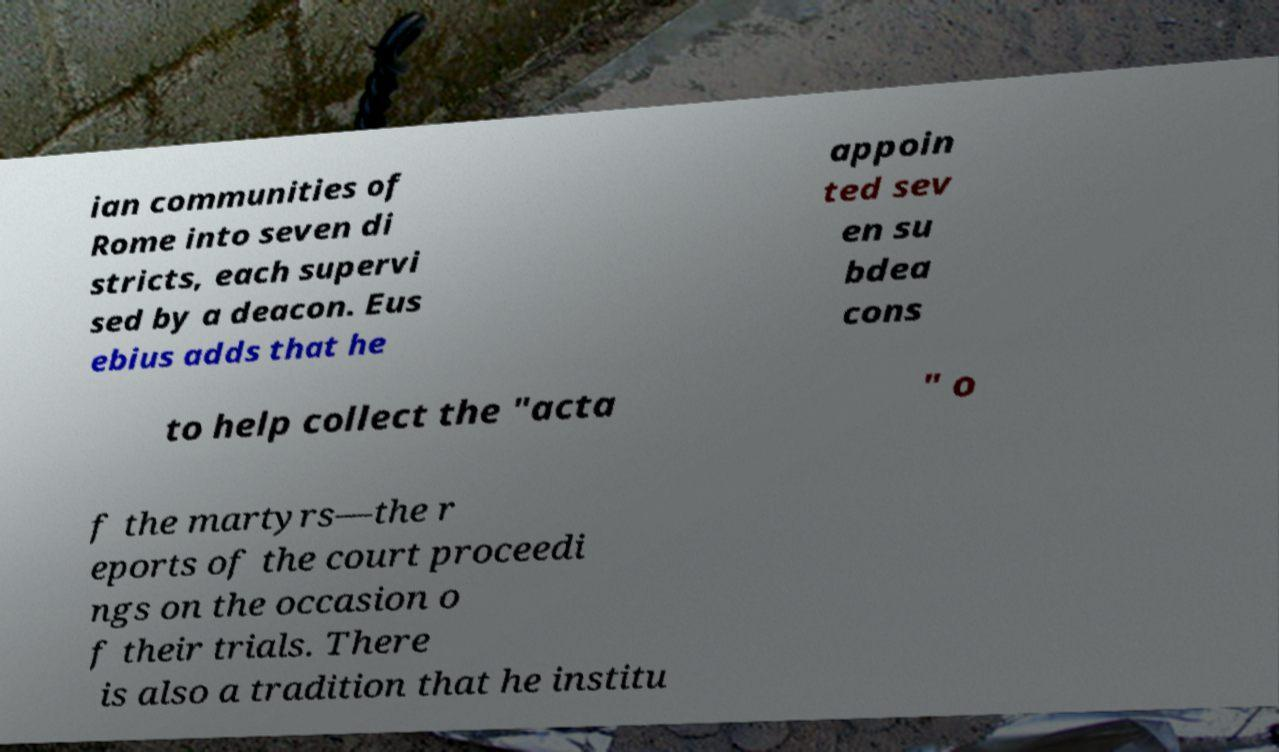What messages or text are displayed in this image? I need them in a readable, typed format. ian communities of Rome into seven di stricts, each supervi sed by a deacon. Eus ebius adds that he appoin ted sev en su bdea cons to help collect the "acta " o f the martyrs—the r eports of the court proceedi ngs on the occasion o f their trials. There is also a tradition that he institu 